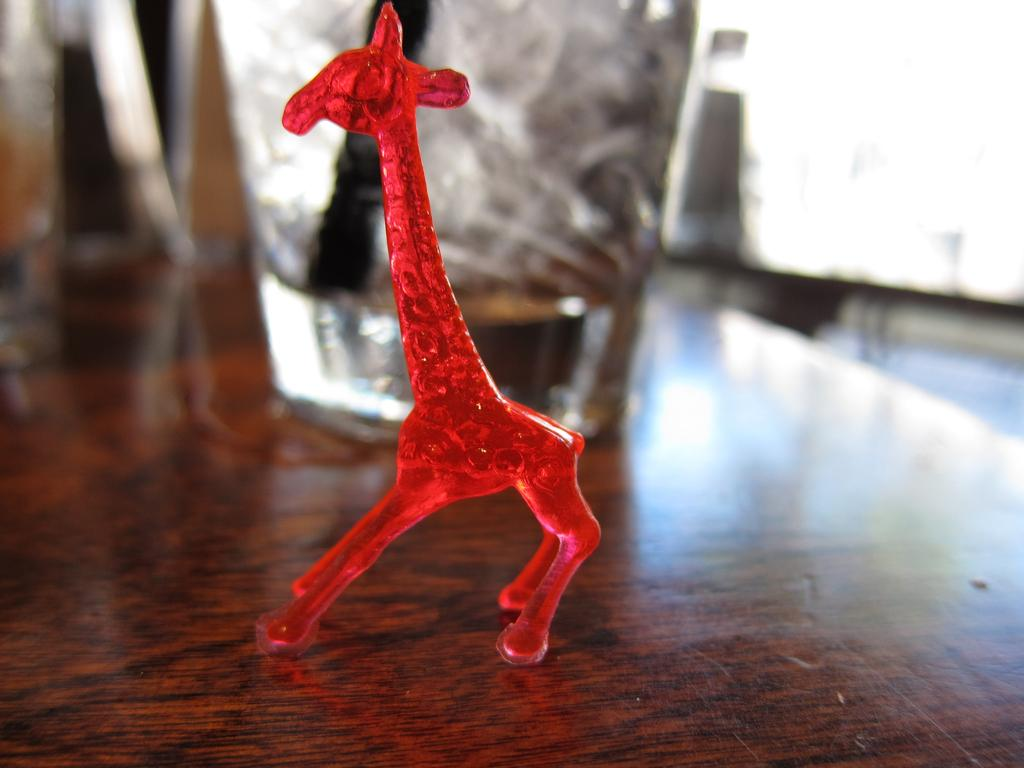What piece of furniture is present in the image? There is a table in the image. What object is placed on the table? There is a glass on the table. What type of toy can be seen on the table? There is a red color toy on the table. What is the purpose of the brick in the image? There is no brick present in the image. 